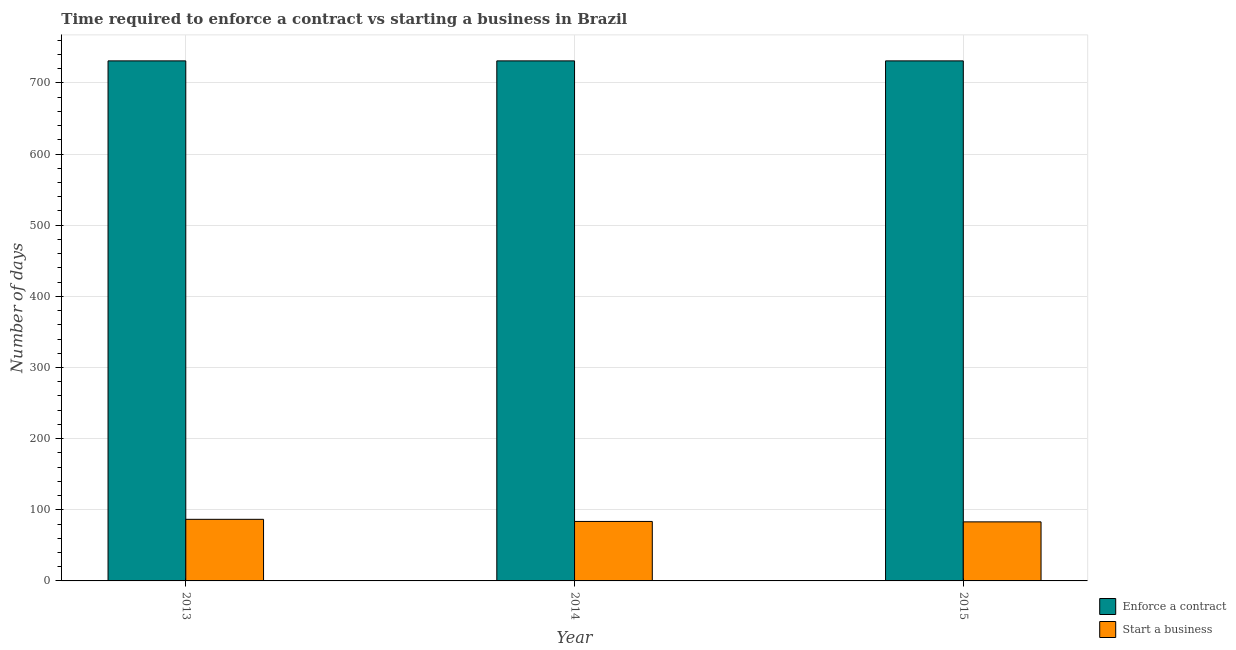How many different coloured bars are there?
Your answer should be very brief. 2. How many groups of bars are there?
Your answer should be compact. 3. Are the number of bars per tick equal to the number of legend labels?
Keep it short and to the point. Yes. How many bars are there on the 3rd tick from the right?
Your response must be concise. 2. What is the label of the 1st group of bars from the left?
Give a very brief answer. 2013. In how many cases, is the number of bars for a given year not equal to the number of legend labels?
Ensure brevity in your answer.  0. What is the number of days to start a business in 2015?
Keep it short and to the point. 83. Across all years, what is the maximum number of days to enforece a contract?
Keep it short and to the point. 731. Across all years, what is the minimum number of days to enforece a contract?
Make the answer very short. 731. In which year was the number of days to enforece a contract minimum?
Give a very brief answer. 2013. What is the total number of days to start a business in the graph?
Your answer should be compact. 253.2. What is the difference between the number of days to start a business in 2014 and that in 2015?
Your response must be concise. 0.6. What is the difference between the number of days to enforece a contract in 2014 and the number of days to start a business in 2013?
Keep it short and to the point. 0. What is the average number of days to start a business per year?
Your response must be concise. 84.4. In the year 2015, what is the difference between the number of days to start a business and number of days to enforece a contract?
Your answer should be compact. 0. In how many years, is the number of days to enforece a contract greater than 360 days?
Provide a short and direct response. 3. What is the ratio of the number of days to start a business in 2013 to that in 2014?
Your answer should be very brief. 1.04. What is the difference between the highest and the second highest number of days to enforece a contract?
Provide a succinct answer. 0. What is the difference between the highest and the lowest number of days to enforece a contract?
Your response must be concise. 0. Is the sum of the number of days to enforece a contract in 2013 and 2015 greater than the maximum number of days to start a business across all years?
Your answer should be very brief. Yes. What does the 2nd bar from the left in 2014 represents?
Your answer should be very brief. Start a business. What does the 1st bar from the right in 2015 represents?
Offer a terse response. Start a business. How many bars are there?
Give a very brief answer. 6. Are all the bars in the graph horizontal?
Offer a terse response. No. Does the graph contain any zero values?
Your response must be concise. No. Does the graph contain grids?
Offer a very short reply. Yes. Where does the legend appear in the graph?
Your answer should be compact. Bottom right. How many legend labels are there?
Offer a terse response. 2. How are the legend labels stacked?
Make the answer very short. Vertical. What is the title of the graph?
Give a very brief answer. Time required to enforce a contract vs starting a business in Brazil. Does "current US$" appear as one of the legend labels in the graph?
Provide a short and direct response. No. What is the label or title of the X-axis?
Make the answer very short. Year. What is the label or title of the Y-axis?
Offer a terse response. Number of days. What is the Number of days in Enforce a contract in 2013?
Keep it short and to the point. 731. What is the Number of days in Start a business in 2013?
Offer a terse response. 86.6. What is the Number of days in Enforce a contract in 2014?
Offer a terse response. 731. What is the Number of days in Start a business in 2014?
Ensure brevity in your answer.  83.6. What is the Number of days of Enforce a contract in 2015?
Your answer should be compact. 731. What is the Number of days of Start a business in 2015?
Your response must be concise. 83. Across all years, what is the maximum Number of days in Enforce a contract?
Ensure brevity in your answer.  731. Across all years, what is the maximum Number of days in Start a business?
Offer a terse response. 86.6. Across all years, what is the minimum Number of days in Enforce a contract?
Provide a succinct answer. 731. What is the total Number of days in Enforce a contract in the graph?
Provide a short and direct response. 2193. What is the total Number of days of Start a business in the graph?
Provide a short and direct response. 253.2. What is the difference between the Number of days in Start a business in 2013 and that in 2014?
Ensure brevity in your answer.  3. What is the difference between the Number of days in Enforce a contract in 2013 and that in 2015?
Offer a terse response. 0. What is the difference between the Number of days of Start a business in 2013 and that in 2015?
Provide a short and direct response. 3.6. What is the difference between the Number of days in Enforce a contract in 2014 and that in 2015?
Give a very brief answer. 0. What is the difference between the Number of days of Enforce a contract in 2013 and the Number of days of Start a business in 2014?
Ensure brevity in your answer.  647.4. What is the difference between the Number of days in Enforce a contract in 2013 and the Number of days in Start a business in 2015?
Keep it short and to the point. 648. What is the difference between the Number of days in Enforce a contract in 2014 and the Number of days in Start a business in 2015?
Ensure brevity in your answer.  648. What is the average Number of days in Enforce a contract per year?
Offer a terse response. 731. What is the average Number of days in Start a business per year?
Make the answer very short. 84.4. In the year 2013, what is the difference between the Number of days in Enforce a contract and Number of days in Start a business?
Your response must be concise. 644.4. In the year 2014, what is the difference between the Number of days in Enforce a contract and Number of days in Start a business?
Offer a terse response. 647.4. In the year 2015, what is the difference between the Number of days of Enforce a contract and Number of days of Start a business?
Offer a very short reply. 648. What is the ratio of the Number of days in Enforce a contract in 2013 to that in 2014?
Make the answer very short. 1. What is the ratio of the Number of days in Start a business in 2013 to that in 2014?
Provide a succinct answer. 1.04. What is the ratio of the Number of days in Start a business in 2013 to that in 2015?
Give a very brief answer. 1.04. What is the ratio of the Number of days in Start a business in 2014 to that in 2015?
Make the answer very short. 1.01. What is the difference between the highest and the second highest Number of days of Enforce a contract?
Keep it short and to the point. 0. What is the difference between the highest and the second highest Number of days of Start a business?
Provide a short and direct response. 3. What is the difference between the highest and the lowest Number of days of Enforce a contract?
Provide a succinct answer. 0. What is the difference between the highest and the lowest Number of days of Start a business?
Provide a short and direct response. 3.6. 